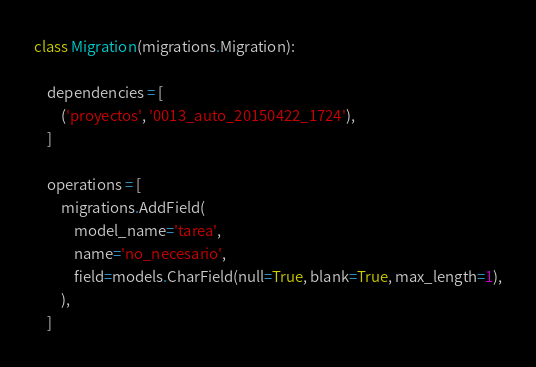Convert code to text. <code><loc_0><loc_0><loc_500><loc_500><_Python_>class Migration(migrations.Migration):

    dependencies = [
        ('proyectos', '0013_auto_20150422_1724'),
    ]

    operations = [
        migrations.AddField(
            model_name='tarea',
            name='no_necesario',
            field=models.CharField(null=True, blank=True, max_length=1),
        ),
    ]
</code> 